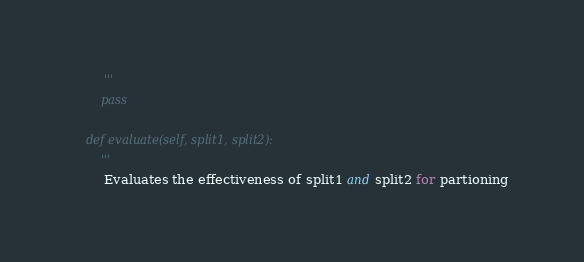Convert code to text. <code><loc_0><loc_0><loc_500><loc_500><_Python_>        '''
        pass

    def evaluate(self, split1, split2):
        '''
        Evaluates the effectiveness of split1 and split2 for partioning </code> 